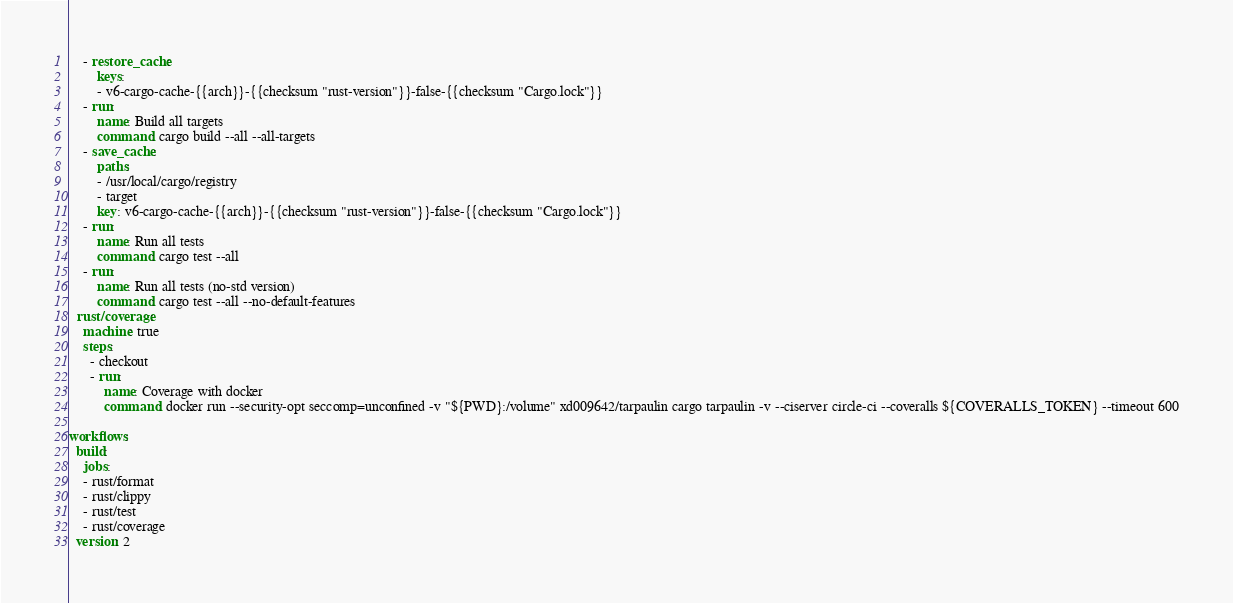<code> <loc_0><loc_0><loc_500><loc_500><_YAML_>    - restore_cache:
        keys:
        - v6-cargo-cache-{{arch}}-{{checksum "rust-version"}}-false-{{checksum "Cargo.lock"}}
    - run:
        name: Build all targets
        command: cargo build --all --all-targets
    - save_cache:
        paths:
        - /usr/local/cargo/registry
        - target
        key: v6-cargo-cache-{{arch}}-{{checksum "rust-version"}}-false-{{checksum "Cargo.lock"}}
    - run:
        name: Run all tests
        command: cargo test --all
    - run:
        name: Run all tests (no-std version)
        command: cargo test --all --no-default-features
  rust/coverage:
    machine: true
    steps:
      - checkout
      - run:
          name: Coverage with docker
          command: docker run --security-opt seccomp=unconfined -v "${PWD}:/volume" xd009642/tarpaulin cargo tarpaulin -v --ciserver circle-ci --coveralls ${COVERALLS_TOKEN} --timeout 600

workflows:
  build:
    jobs:
    - rust/format
    - rust/clippy
    - rust/test
    - rust/coverage
  version: 2
</code> 